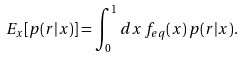<formula> <loc_0><loc_0><loc_500><loc_500>E _ { x } [ p ( r | x ) ] = \int _ { 0 } ^ { 1 } d x \, f _ { e q } ( x ) \, p ( r | x ) .</formula> 